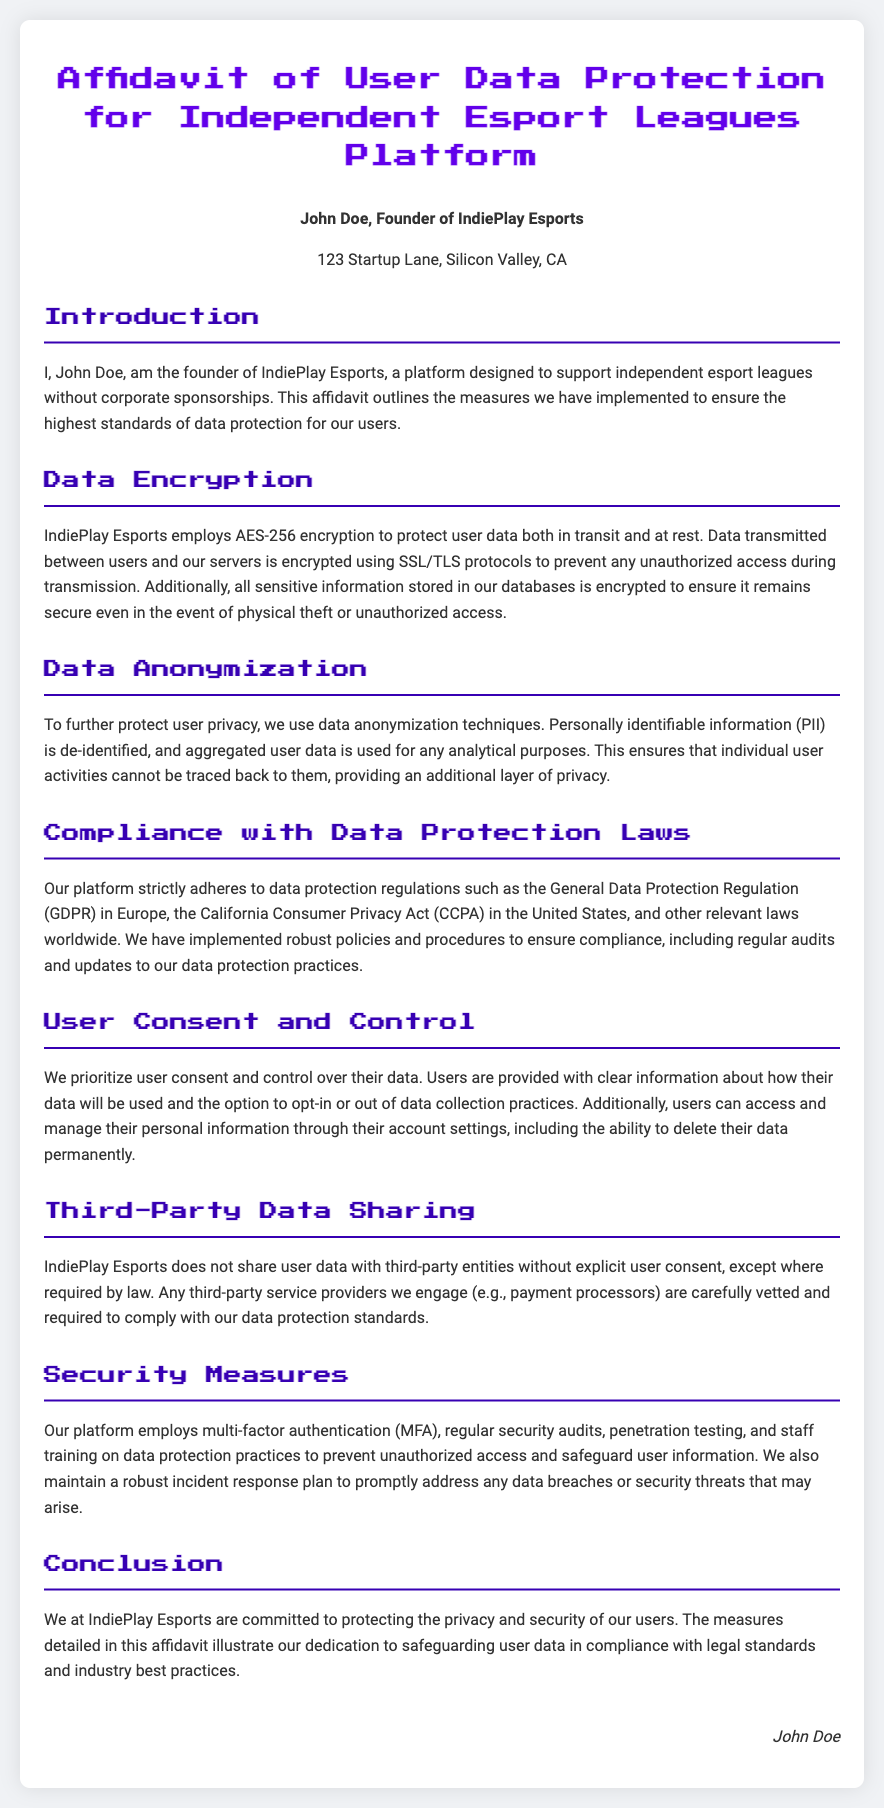What is the encryption standard used? The document states that IndiePlay Esports employs AES-256 encryption to protect user data.
Answer: AES-256 Who is the founder of IndiePlay Esports? The name of the founder is mentioned in the affidavit as John Doe.
Answer: John Doe What user data protection regulation is mentioned for Europe? The regulation specified in the document for Europe is the General Data Protection Regulation.
Answer: GDPR What is used for data transmission protection? The document explains that SSL/TLS protocols are used for protecting data transmitted between users and servers.
Answer: SSL/TLS How does IndiePlay Esports provide options for user data management? The affidavit indicates that users can access and manage their personal information through their account settings.
Answer: Account settings What type of authentication is employed for security? The document mentions the use of multi-factor authentication for security measures.
Answer: Multi-factor authentication What is the purpose of data anonymization mentioned in the document? The affidavit states that data anonymization techniques are used to de-identify personally identifiable information.
Answer: De-identify PII Are third-party service providers vetted? It is indicated in the affidavit that third-party service providers are carefully vetted.
Answer: Yes What is the signing person's title? The document identifies John Doe as the Founder of IndiePlay Esports.
Answer: Founder 